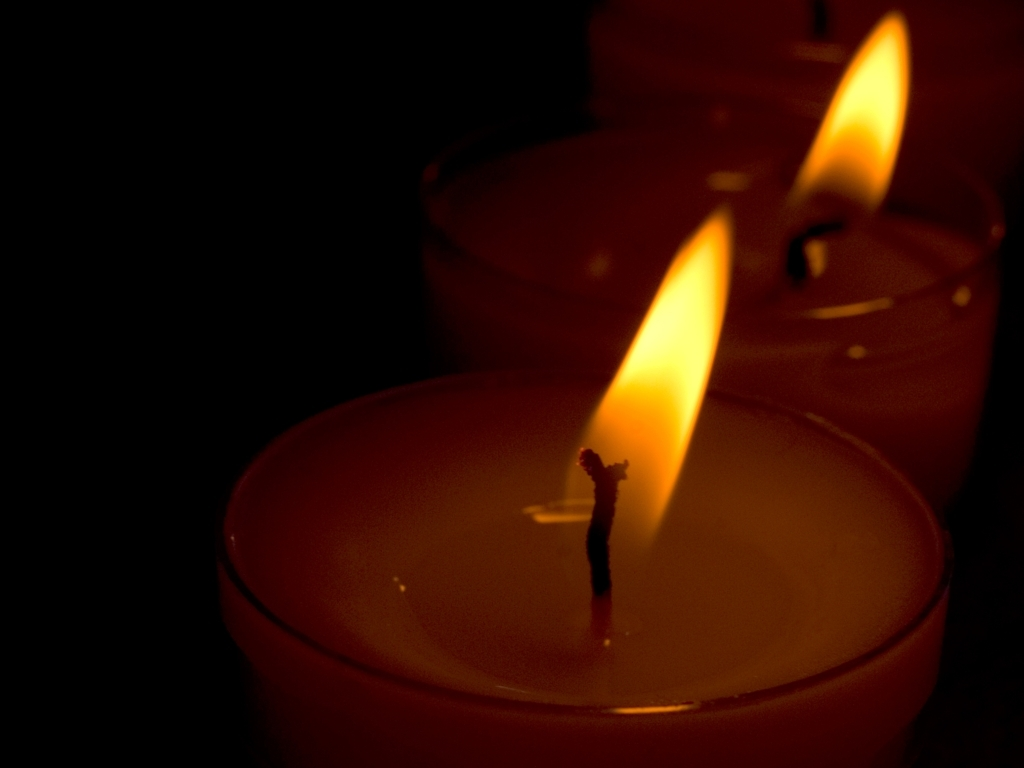Can you describe the setting and possible significance of the candlelight in this picture? The image shows a close-up of lit candles in a dimly lit environment which suggests a serene and intimate setting. The candlelight's soft illumination is often associated with introspection, remembrance, or celebration. This setting could be significant in rituals, religious services, romantic dinners, or even power outages to provide light in a practical sense. 